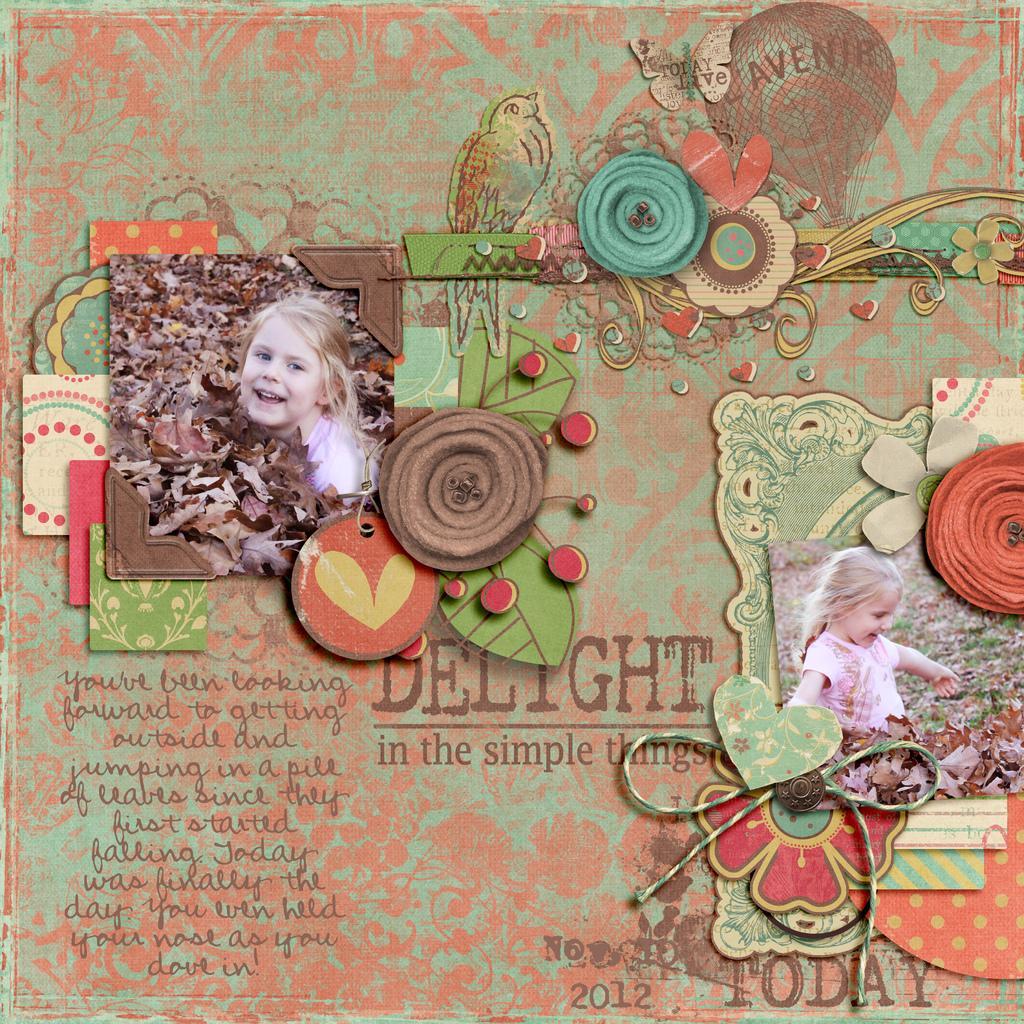Can you describe this image briefly? In this picture we can see a card, here we can see photos of two people, leaves, bird, butterfly and some text. 